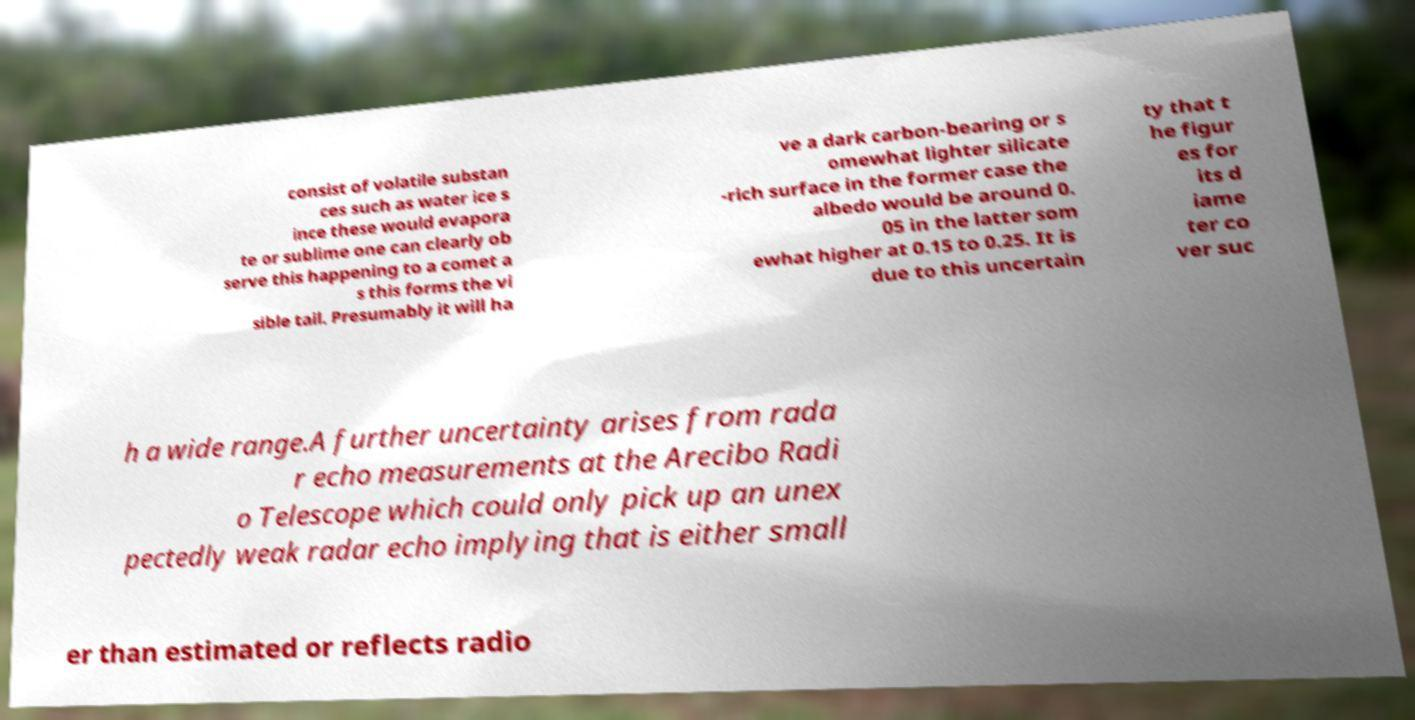Could you extract and type out the text from this image? consist of volatile substan ces such as water ice s ince these would evapora te or sublime one can clearly ob serve this happening to a comet a s this forms the vi sible tail. Presumably it will ha ve a dark carbon-bearing or s omewhat lighter silicate -rich surface in the former case the albedo would be around 0. 05 in the latter som ewhat higher at 0.15 to 0.25. It is due to this uncertain ty that t he figur es for its d iame ter co ver suc h a wide range.A further uncertainty arises from rada r echo measurements at the Arecibo Radi o Telescope which could only pick up an unex pectedly weak radar echo implying that is either small er than estimated or reflects radio 